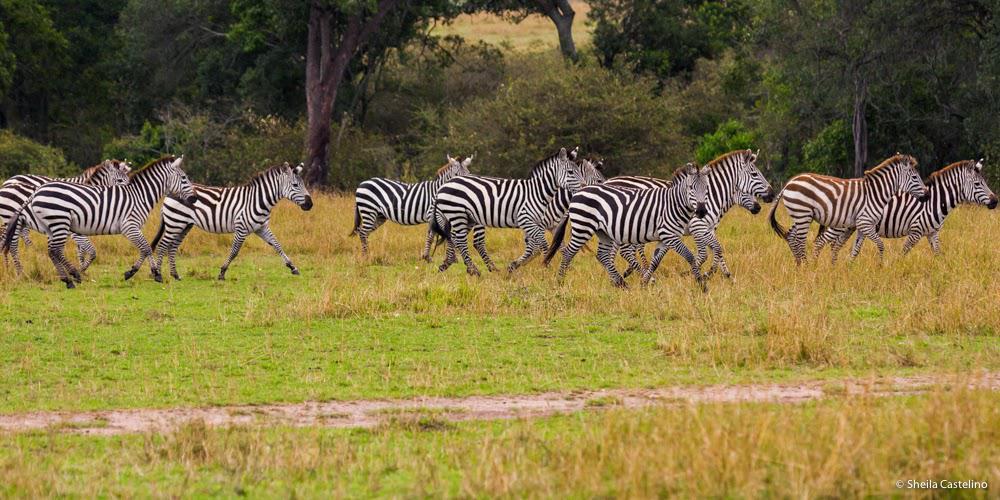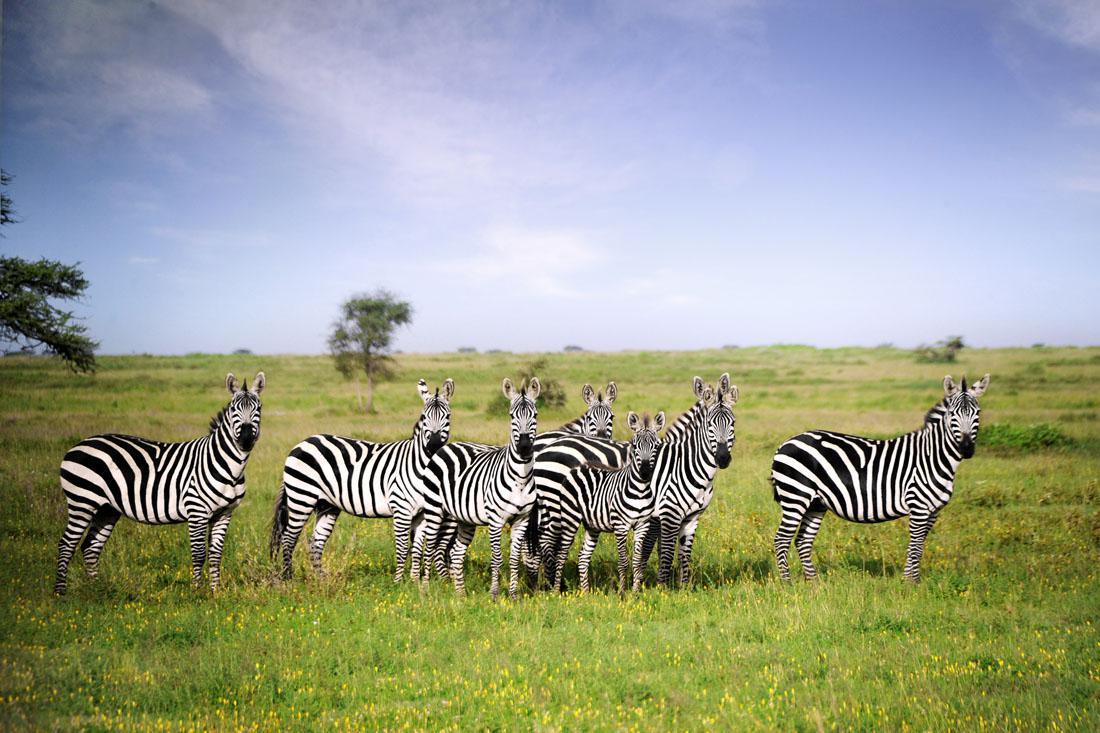The first image is the image on the left, the second image is the image on the right. Considering the images on both sides, is "In at least one image is a row of zebra going right and in the other image there is is a large group of zebra in different directions." valid? Answer yes or no. No. The first image is the image on the left, the second image is the image on the right. Examine the images to the left and right. Is the description "The right image features a row of zebras with their bodies facing rightward." accurate? Answer yes or no. Yes. 